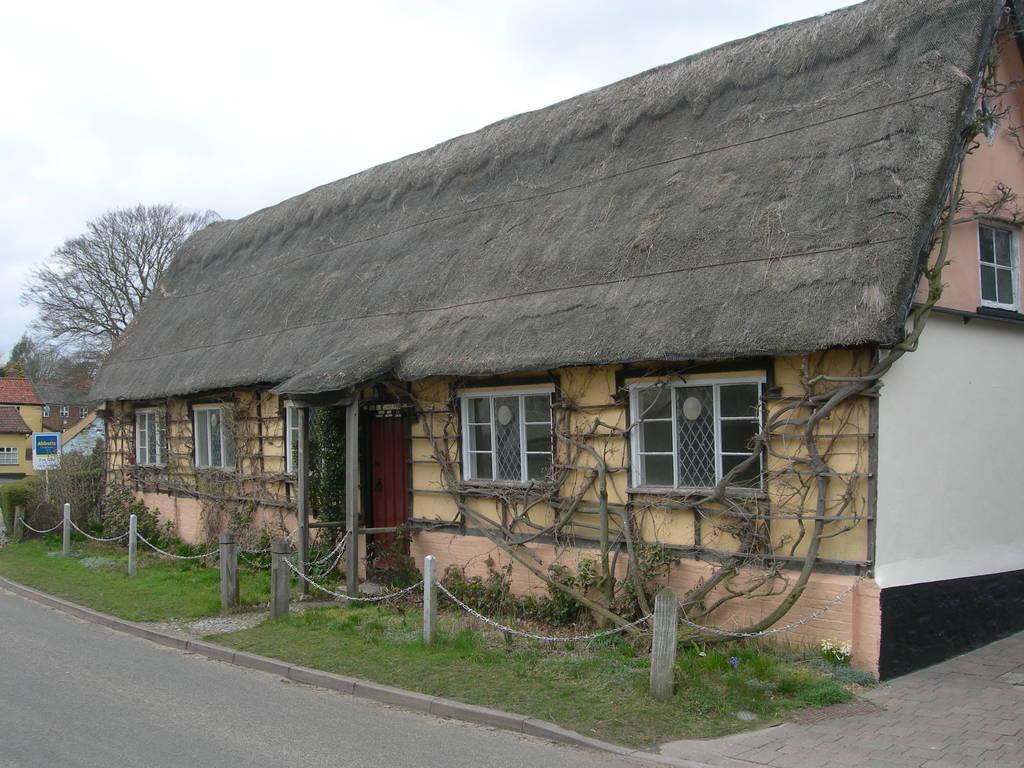Please provide a concise description of this image. In this image we can see few houses. There are many trees and plants in the image. There is a sky and a road in the image. There is a grassy land in the image. 